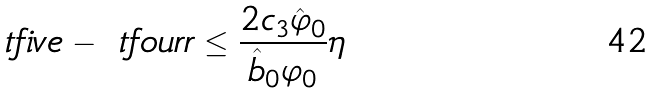Convert formula to latex. <formula><loc_0><loc_0><loc_500><loc_500>\ t f i v e - \ t f o u r r \leq \frac { 2 c _ { 3 } \hat { \varphi } _ { 0 } } { \hat { b } _ { 0 } \varphi _ { 0 } } \eta</formula> 